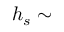<formula> <loc_0><loc_0><loc_500><loc_500>h _ { s } \sim</formula> 